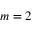<formula> <loc_0><loc_0><loc_500><loc_500>m = 2</formula> 